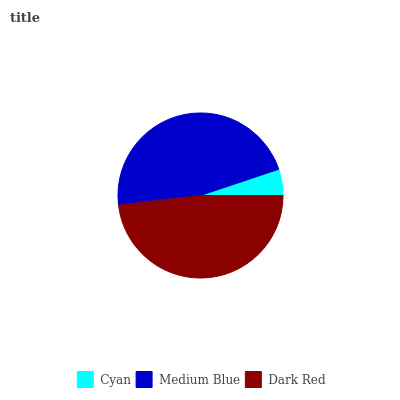Is Cyan the minimum?
Answer yes or no. Yes. Is Dark Red the maximum?
Answer yes or no. Yes. Is Medium Blue the minimum?
Answer yes or no. No. Is Medium Blue the maximum?
Answer yes or no. No. Is Medium Blue greater than Cyan?
Answer yes or no. Yes. Is Cyan less than Medium Blue?
Answer yes or no. Yes. Is Cyan greater than Medium Blue?
Answer yes or no. No. Is Medium Blue less than Cyan?
Answer yes or no. No. Is Medium Blue the high median?
Answer yes or no. Yes. Is Medium Blue the low median?
Answer yes or no. Yes. Is Dark Red the high median?
Answer yes or no. No. Is Dark Red the low median?
Answer yes or no. No. 